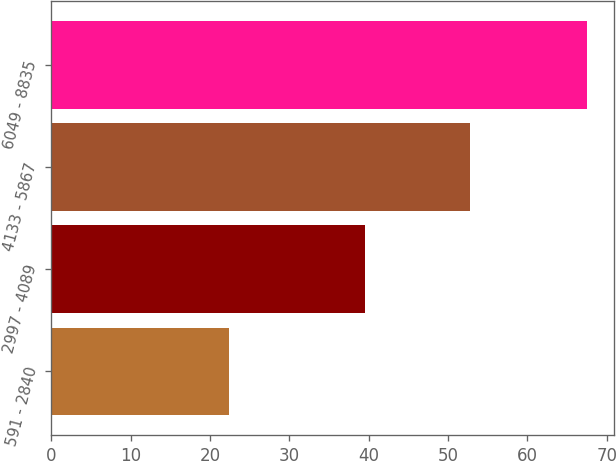<chart> <loc_0><loc_0><loc_500><loc_500><bar_chart><fcel>591 - 2840<fcel>2997 - 4089<fcel>4133 - 5867<fcel>6049 - 8835<nl><fcel>22.44<fcel>39.53<fcel>52.77<fcel>67.55<nl></chart> 